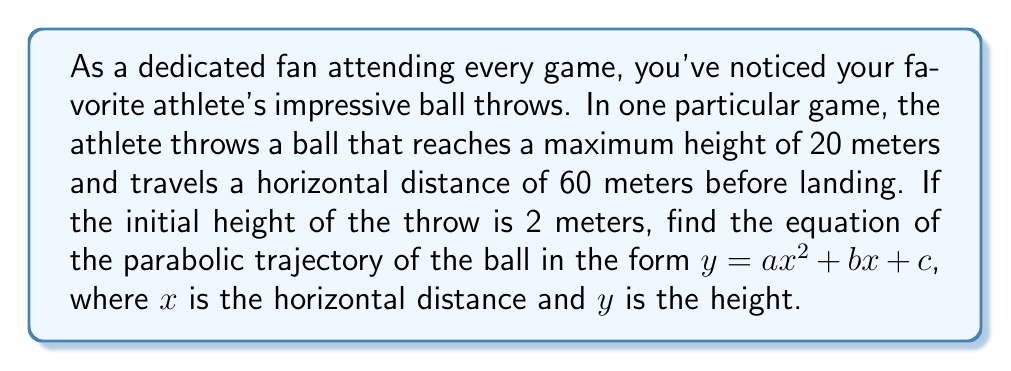Help me with this question. Let's approach this step-by-step:

1) The general form of a parabola is $y = ax^2 + bx + c$, where:
   $a$ determines the direction and steepness of the parabola
   $b$ affects the axis of symmetry
   $c$ is the y-intercept (initial height in this case)

2) We know three points on this parabola:
   $(0, 2)$ - the starting point
   $(30, 20)$ - the vertex (highest point)
   $(60, 2)$ - the ending point

3) We can use $c = 2$ since this is the initial height.

4) For a parabola, the axis of symmetry is halfway between the start and end points:
   $x = \frac{60}{2} = 30$

5) We can use the vertex form of a parabola: $y = a(x-h)^2 + k$
   Where $(h,k)$ is the vertex, in this case $(30, 20)$

6) Substituting our known values:
   $20 = a(30-30)^2 + 20$
   $2 = a(0-30)^2 + 20$
   $2 = a(60-30)^2 + 20$

7) From the last equation:
   $2 = 900a + 20$
   $-18 = 900a$
   $a = -\frac{1}{50}$

8) Now we have: $y = -\frac{1}{50}(x-30)^2 + 20$

9) Expanding this:
   $y = -\frac{1}{50}(x^2 - 60x + 900) + 20$
   $y = -\frac{1}{50}x^2 + \frac{6}{5}x - 18 + 20$
   $y = -\frac{1}{50}x^2 + \frac{6}{5}x + 2$

Therefore, the equation of the parabolic trajectory is:

$$y = -\frac{1}{50}x^2 + \frac{6}{5}x + 2$$
Answer: $y = -\frac{1}{50}x^2 + \frac{6}{5}x + 2$ 